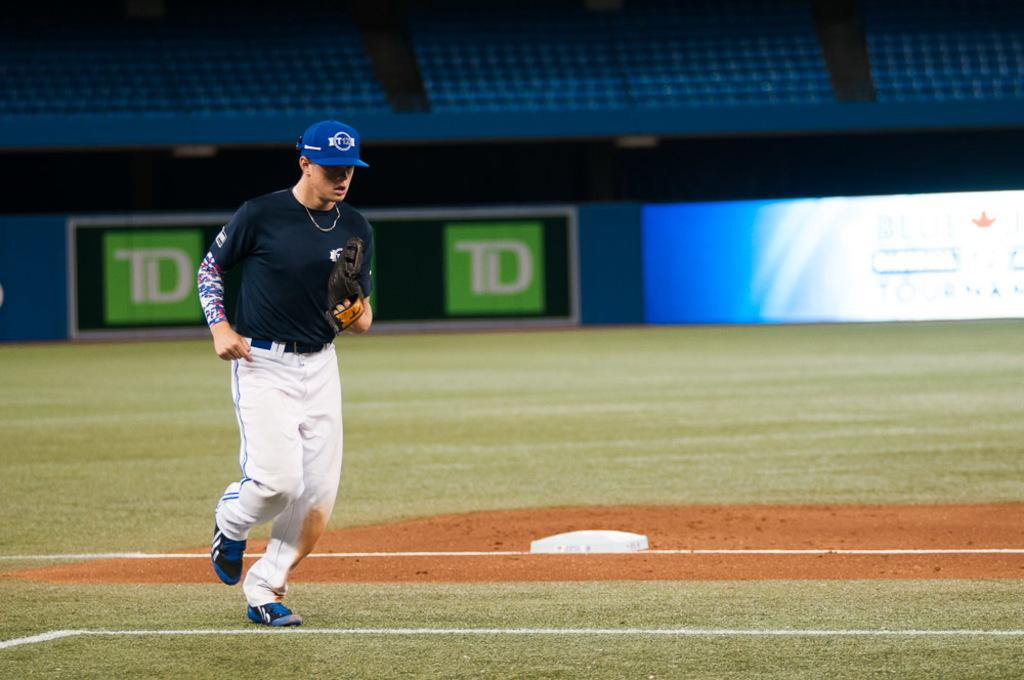<image>
Relay a brief, clear account of the picture shown. A baseball player is running on a field in front of a TD sign. 